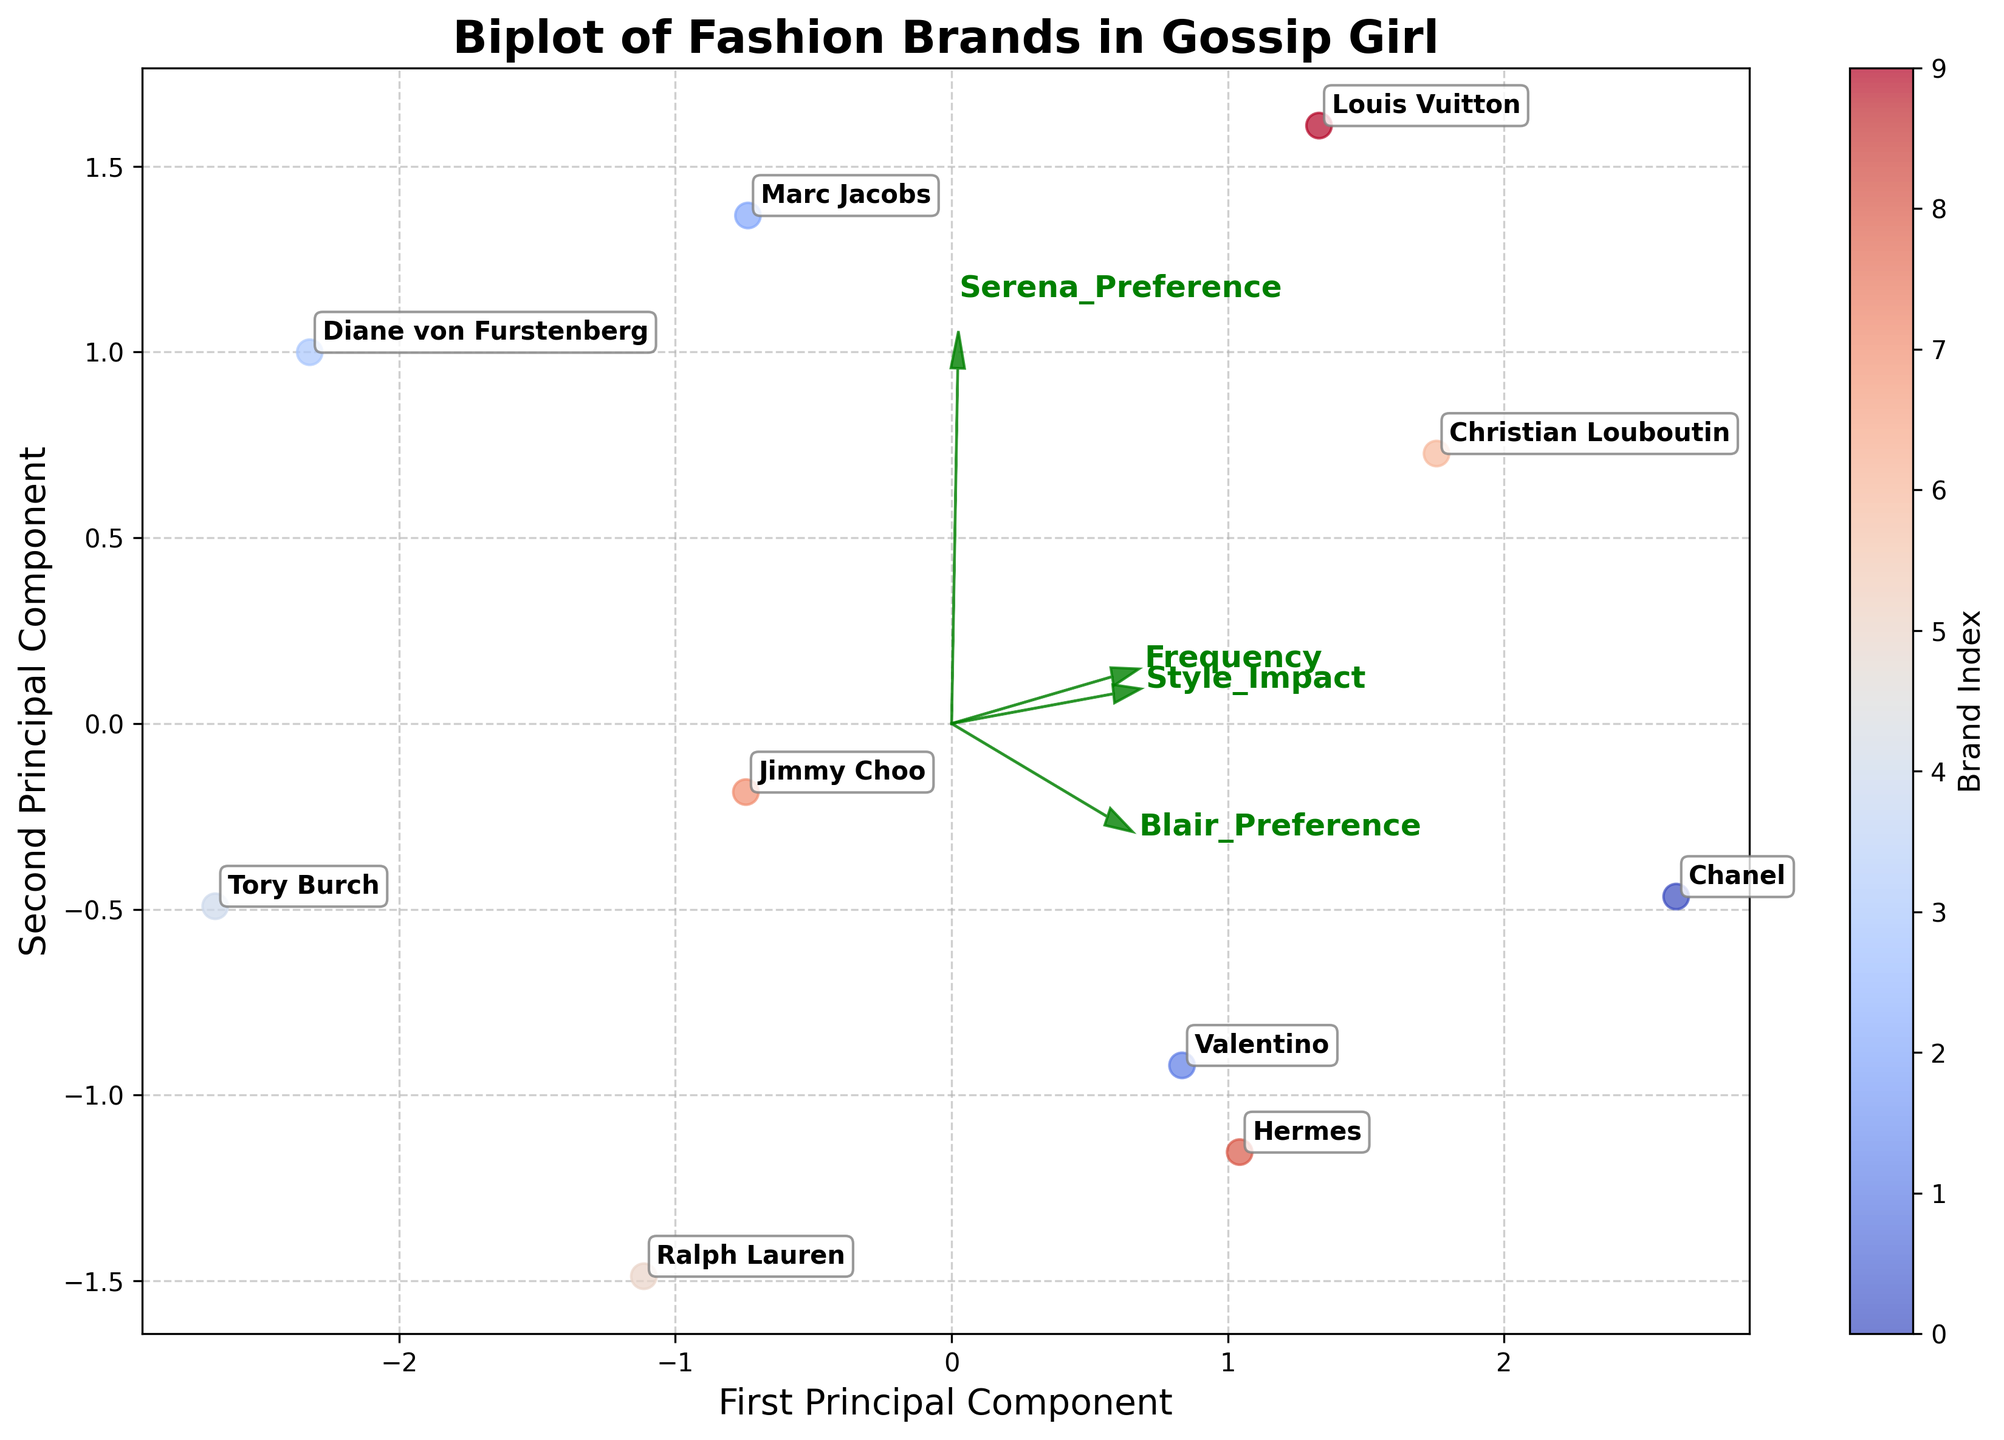What is the title of the plot? The title of the plot is displayed prominently at the top of the figure. By reading the text at the top, you can find out.
Answer: Biplot of Fashion Brands in Gossip Girl How many brands are plotted in the biplot? Each brand is represented by a labeled point in the plot. By counting these labels, you can determine the number of brands. There are 10 brands labeled in the plot.
Answer: 10 Which axis represents the "First Principal Component"? The axis representing the "First Principal Component" can be identified by reading the axis labels. The label on the x-axis corresponds to the "First Principal Component".
Answer: x-axis Which two brands have the highest preference by Blair? To find this, look at the positions of brands along the axes labeled "Blair_Preference". The two brands closest to the "Blair_Preference" vector or high values along this component should be considered.
Answer: Chanel and Christian Louboutin Which brand does not align strongly with any of the principal components? A brand that does not align strongly with any principal component will appear closer to the origin (0,0) and away from feature arrows. By examining the plot, you can identify it.
Answer: Tory Burch What are the first and second principal components' directions for "Style_Impact"? The direction of "Style_Impact" is indicated by an arrow. By looking at the orientation and endpoints of the arrow from the origin, you can determine its direction on both components.
Answer: It points rightward (positive) on the First Principal Component and upward (positive) on the Second Principal Component Which brands have more influence by the First Principal Component than the Second? Brands influenced more by the First Principal Component will lie farther along the First Principal Component axis compared to the Second. By examining their positions relative to the axes, you can determine this.
Answer: Marc Jacobs, Diane von Furstenberg, Tory Burch, Jimmy Choo Between Chanel and Valentino, which has a higher "Frequency"? By analyzing the positions of Chanel and Valentino along the "Frequency" vector, you can see which brand is positioned further in the direction the "Frequency" vector points to. Brands further along this vector have higher "Frequency".
Answer: Chanel Which principal component (First or Second) has a stronger association with "Serena_Preference"? By examining the orientation of the "Serena_Preference" arrow relative to each principal component, you can identify which component it aligns more strongly with.
Answer: Second Principal Component Does Louis Vuitton appear closer to "Style_Impact" or "Serena_Preference" vector? By visually comparing the proximity of Louis Vuitton to the arrows representing "Style_Impact" and "Serena_Preference", you can see which vector it is closer to.
Answer: Serena_Preference 